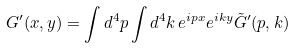Convert formula to latex. <formula><loc_0><loc_0><loc_500><loc_500>G ^ { \prime } ( x , y ) = \int d ^ { 4 } p \int d ^ { 4 } k \, e ^ { i p x } e ^ { i k y } \tilde { G } ^ { \prime } ( p , k )</formula> 